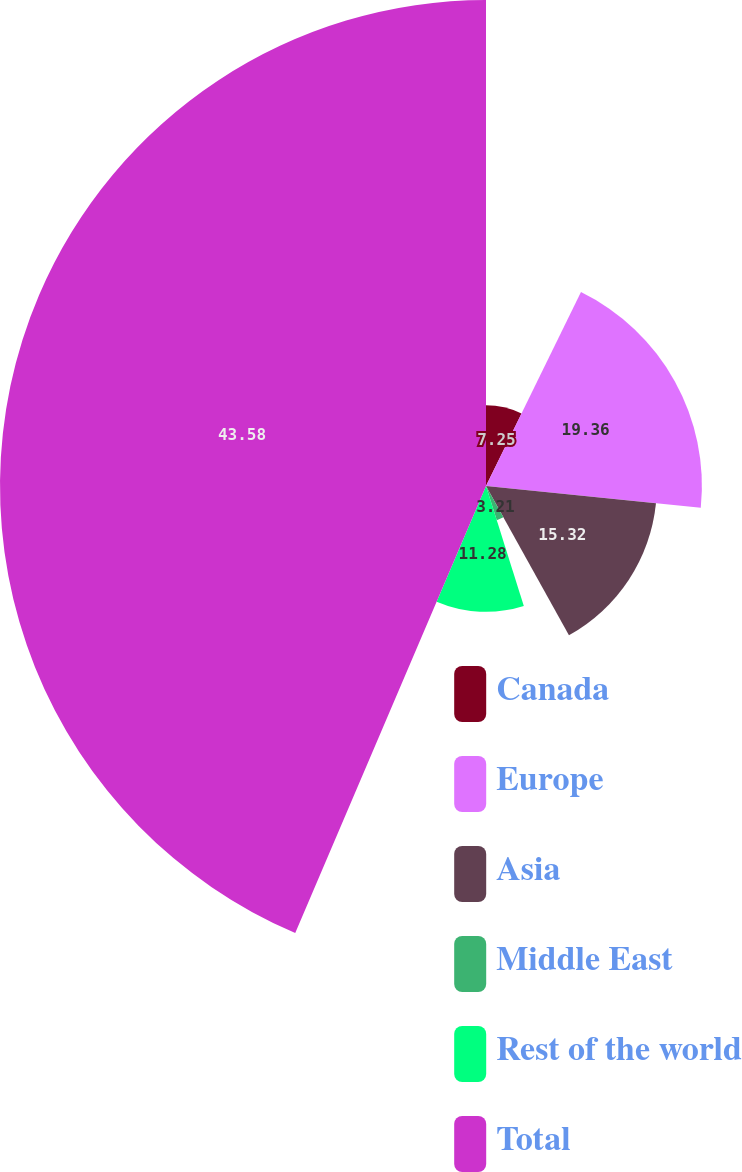Convert chart. <chart><loc_0><loc_0><loc_500><loc_500><pie_chart><fcel>Canada<fcel>Europe<fcel>Asia<fcel>Middle East<fcel>Rest of the world<fcel>Total<nl><fcel>7.25%<fcel>19.36%<fcel>15.32%<fcel>3.21%<fcel>11.28%<fcel>43.58%<nl></chart> 